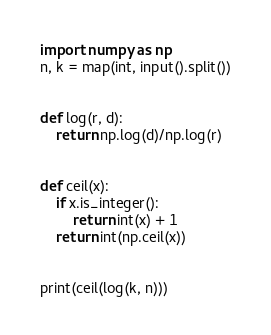<code> <loc_0><loc_0><loc_500><loc_500><_Python_>import numpy as np
n, k = map(int, input().split())


def log(r, d):
    return np.log(d)/np.log(r)


def ceil(x):
    if x.is_integer():
        return int(x) + 1
    return int(np.ceil(x))


print(ceil(log(k, n)))</code> 